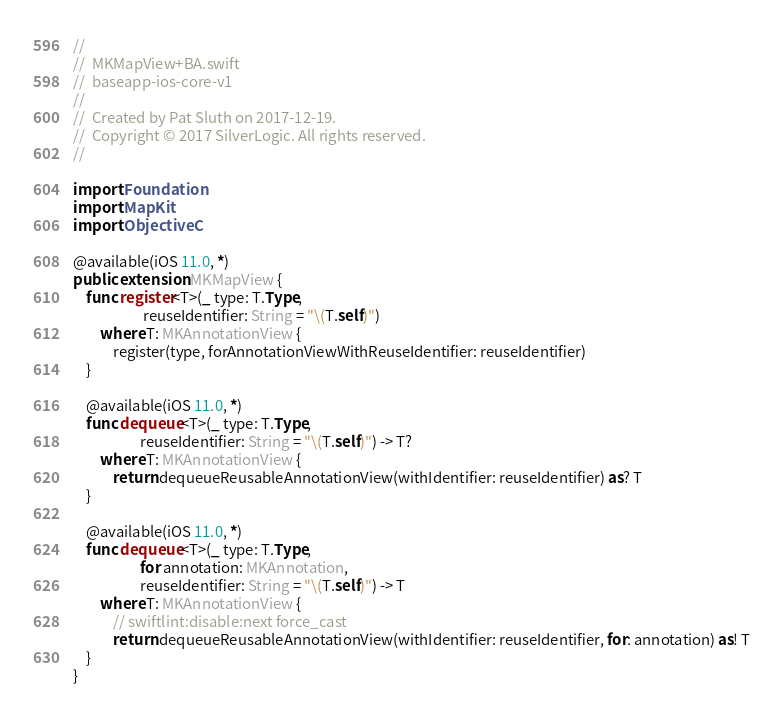<code> <loc_0><loc_0><loc_500><loc_500><_Swift_>//
//  MKMapView+BA.swift
//  baseapp-ios-core-v1
//
//  Created by Pat Sluth on 2017-12-19.
//  Copyright © 2017 SilverLogic. All rights reserved.
//

import Foundation
import MapKit
import ObjectiveC

@available(iOS 11.0, *)
public extension MKMapView {
    func register<T>(_ type: T.Type,
                     reuseIdentifier: String = "\(T.self)")
        where T: MKAnnotationView {
            register(type, forAnnotationViewWithReuseIdentifier: reuseIdentifier)
    }
    
    @available(iOS 11.0, *)
    func dequeue<T>(_ type: T.Type,
                    reuseIdentifier: String = "\(T.self)") -> T?
        where T: MKAnnotationView {
            return dequeueReusableAnnotationView(withIdentifier: reuseIdentifier) as? T
    }
    
    @available(iOS 11.0, *)
    func dequeue<T>(_ type: T.Type,
                    for annotation: MKAnnotation,
                    reuseIdentifier: String = "\(T.self)") -> T
        where T: MKAnnotationView {
            // swiftlint:disable:next force_cast
            return dequeueReusableAnnotationView(withIdentifier: reuseIdentifier, for: annotation) as! T
    }
}
</code> 